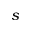<formula> <loc_0><loc_0><loc_500><loc_500>s</formula> 